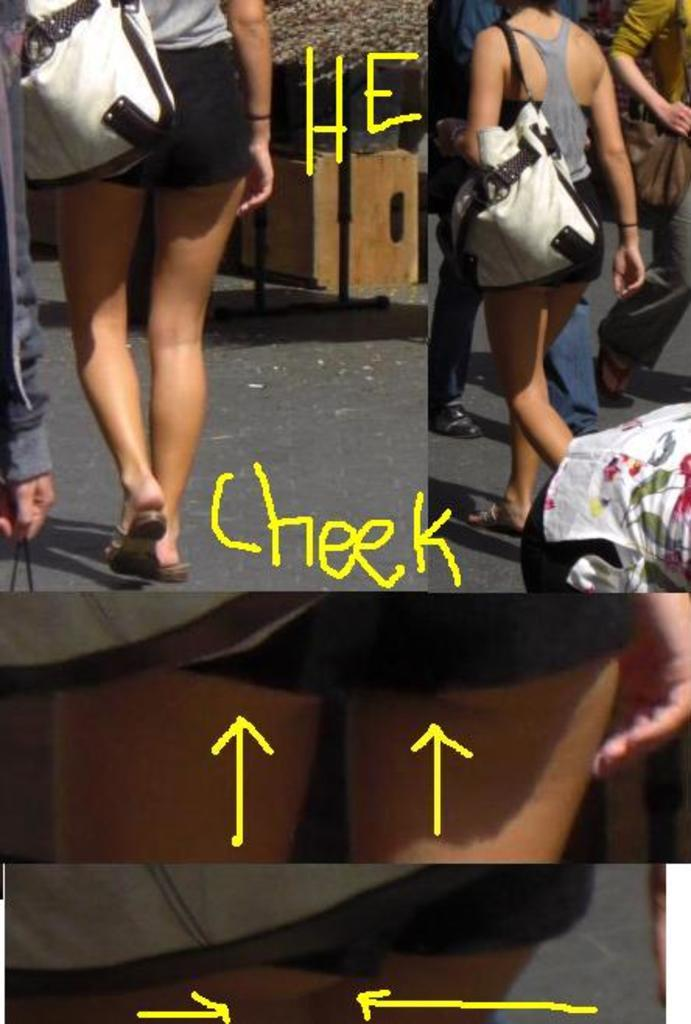Who is the main subject in the image? There is a woman in the image. What is the woman doing in the image? The woman is walking. What accessory is the woman wearing in the image? The woman is wearing a handbag. What type of pot can be seen on the woman's nose in the image? There is no pot present on the woman's nose in the image. 